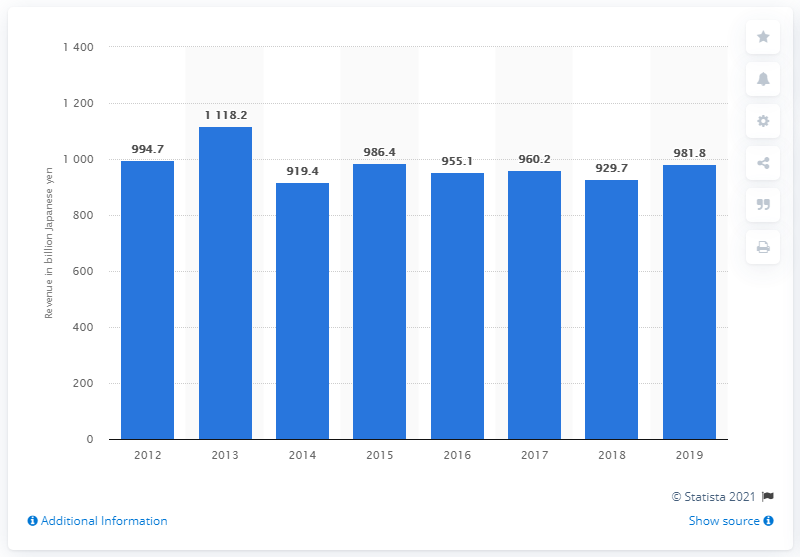Indicate a few pertinent items in this graphic. In the fiscal year 2019, the revenue of Daiichi Sankyo was 981.8 billion yen. 